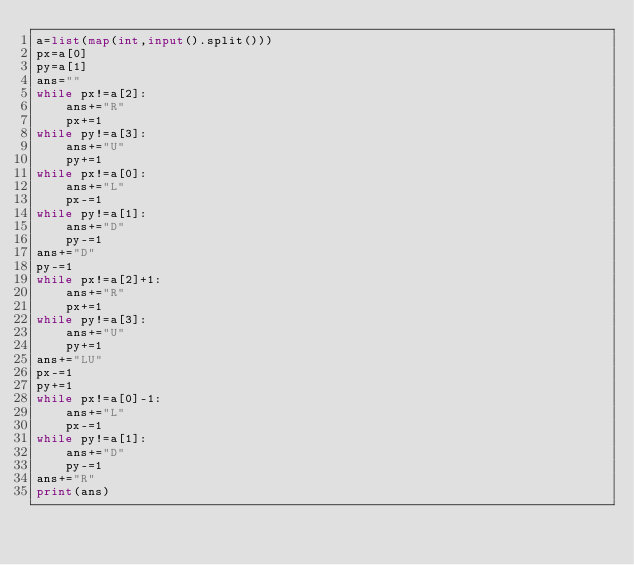Convert code to text. <code><loc_0><loc_0><loc_500><loc_500><_Python_>a=list(map(int,input().split()))
px=a[0]
py=a[1]
ans=""
while px!=a[2]:
    ans+="R"
    px+=1
while py!=a[3]:
    ans+="U"
    py+=1
while px!=a[0]:
    ans+="L"
    px-=1
while py!=a[1]:
    ans+="D"
    py-=1
ans+="D"
py-=1
while px!=a[2]+1:
    ans+="R"
    px+=1
while py!=a[3]:
    ans+="U"
    py+=1
ans+="LU"
px-=1
py+=1
while px!=a[0]-1:
    ans+="L"
    px-=1
while py!=a[1]:
    ans+="D"
    py-=1
ans+="R"
print(ans)</code> 